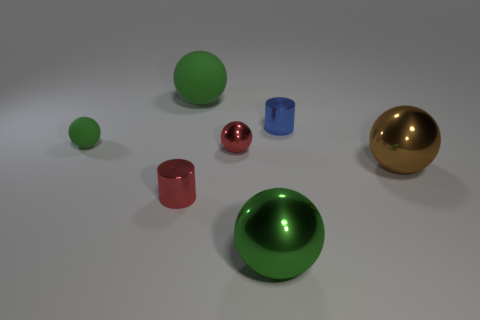Can you describe the lighting in this scene? The lighting in the scene appears to be soft and diffused, creating gentle shadows that spread out from the objects. There are no harsh or strongly defined shadows, suggesting that the light source is not very close to the objects, or there could be multiple sources creating an even illumination across the scene. 